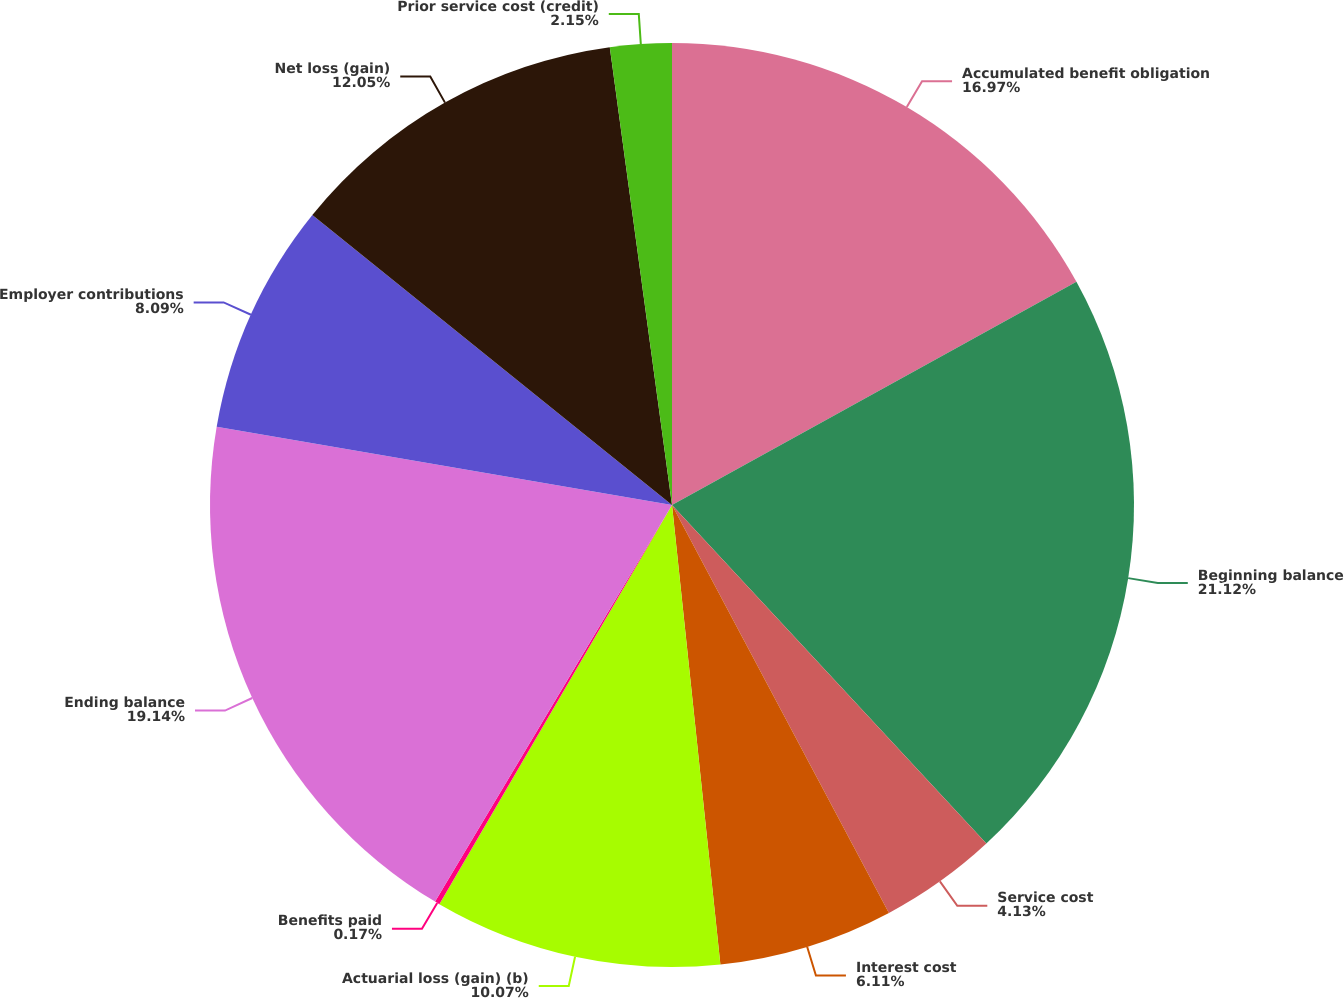<chart> <loc_0><loc_0><loc_500><loc_500><pie_chart><fcel>Accumulated benefit obligation<fcel>Beginning balance<fcel>Service cost<fcel>Interest cost<fcel>Actuarial loss (gain) (b)<fcel>Benefits paid<fcel>Ending balance<fcel>Employer contributions<fcel>Net loss (gain)<fcel>Prior service cost (credit)<nl><fcel>16.97%<fcel>21.12%<fcel>4.13%<fcel>6.11%<fcel>10.07%<fcel>0.17%<fcel>19.14%<fcel>8.09%<fcel>12.05%<fcel>2.15%<nl></chart> 